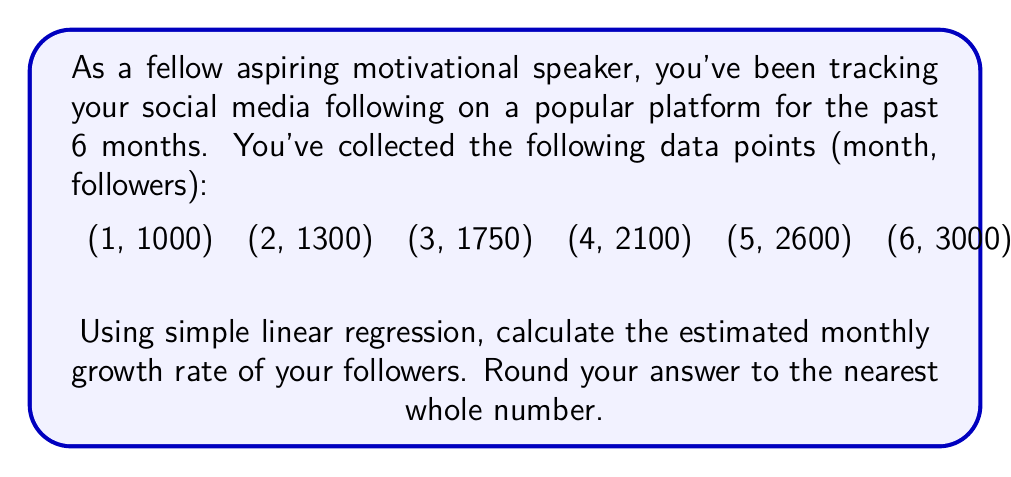Solve this math problem. To calculate the estimated monthly growth rate using simple linear regression, we'll follow these steps:

1) First, let's define our variables:
   $x$ = month number
   $y$ = number of followers

2) We need to calculate the following sums:
   $\sum x$, $\sum y$, $\sum xy$, $\sum x^2$

   $\sum x = 1 + 2 + 3 + 4 + 5 + 6 = 21$
   $\sum y = 1000 + 1300 + 1750 + 2100 + 2600 + 3000 = 11750$
   $\sum xy = 1(1000) + 2(1300) + 3(1750) + 4(2100) + 5(2600) + 6(3000) = 51100$
   $\sum x^2 = 1^2 + 2^2 + 3^2 + 4^2 + 5^2 + 6^2 = 91$

3) Now we can use the formula for the slope (b) in simple linear regression:

   $$b = \frac{n\sum xy - \sum x \sum y}{n\sum x^2 - (\sum x)^2}$$

   Where $n$ is the number of data points (6 in this case).

4) Let's substitute our values:

   $$b = \frac{6(51100) - 21(11750)}{6(91) - 21^2}$$

   $$b = \frac{306600 - 246750}{546 - 441}$$

   $$b = \frac{59850}{105} = 570$$

5) The slope $b$ represents the average increase in followers per month, which is our monthly growth rate.
Answer: 570 followers per month 